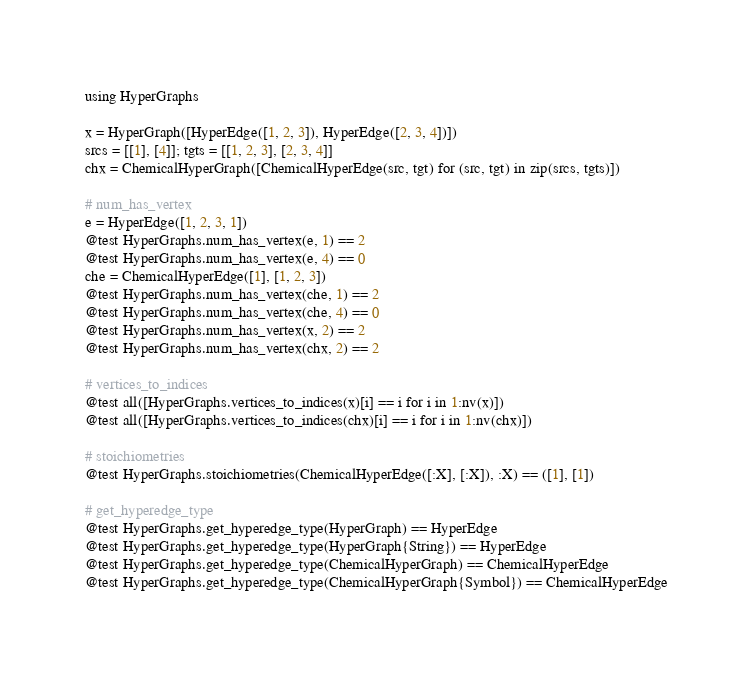<code> <loc_0><loc_0><loc_500><loc_500><_Julia_>using HyperGraphs

x = HyperGraph([HyperEdge([1, 2, 3]), HyperEdge([2, 3, 4])])
srcs = [[1], [4]]; tgts = [[1, 2, 3], [2, 3, 4]]
chx = ChemicalHyperGraph([ChemicalHyperEdge(src, tgt) for (src, tgt) in zip(srcs, tgts)])

# num_has_vertex
e = HyperEdge([1, 2, 3, 1])
@test HyperGraphs.num_has_vertex(e, 1) == 2
@test HyperGraphs.num_has_vertex(e, 4) == 0
che = ChemicalHyperEdge([1], [1, 2, 3])
@test HyperGraphs.num_has_vertex(che, 1) == 2
@test HyperGraphs.num_has_vertex(che, 4) == 0
@test HyperGraphs.num_has_vertex(x, 2) == 2
@test HyperGraphs.num_has_vertex(chx, 2) == 2

# vertices_to_indices
@test all([HyperGraphs.vertices_to_indices(x)[i] == i for i in 1:nv(x)])
@test all([HyperGraphs.vertices_to_indices(chx)[i] == i for i in 1:nv(chx)])

# stoichiometries
@test HyperGraphs.stoichiometries(ChemicalHyperEdge([:X], [:X]), :X) == ([1], [1])

# get_hyperedge_type
@test HyperGraphs.get_hyperedge_type(HyperGraph) == HyperEdge
@test HyperGraphs.get_hyperedge_type(HyperGraph{String}) == HyperEdge
@test HyperGraphs.get_hyperedge_type(ChemicalHyperGraph) == ChemicalHyperEdge
@test HyperGraphs.get_hyperedge_type(ChemicalHyperGraph{Symbol}) == ChemicalHyperEdge
</code> 